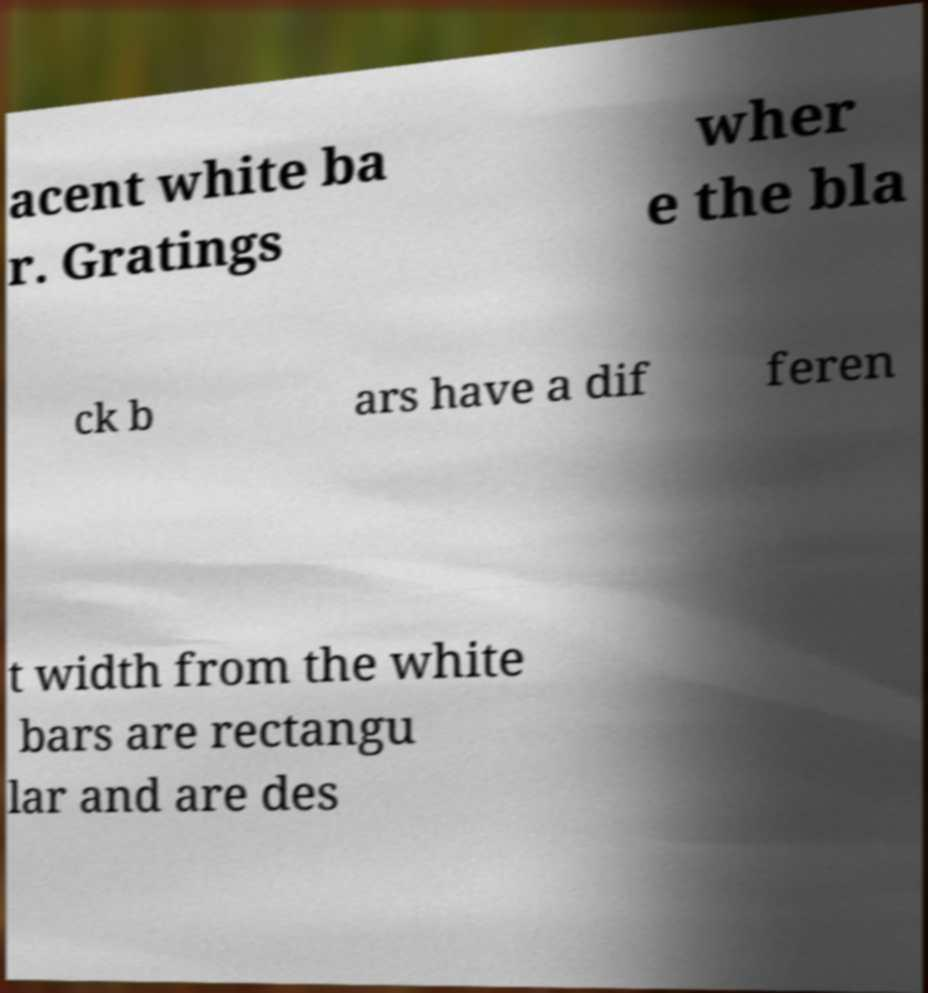For documentation purposes, I need the text within this image transcribed. Could you provide that? acent white ba r. Gratings wher e the bla ck b ars have a dif feren t width from the white bars are rectangu lar and are des 